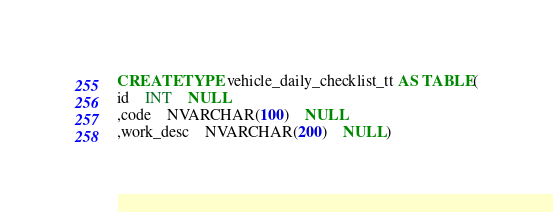Convert code to text. <code><loc_0><loc_0><loc_500><loc_500><_SQL_>CREATE TYPE vehicle_daily_checklist_tt AS TABLE(
id	INT	NULL
,code	NVARCHAR(100)	NULL
,work_desc	NVARCHAR(200)	NULL)</code> 